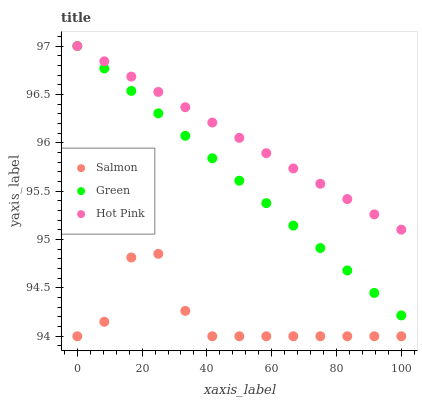Does Salmon have the minimum area under the curve?
Answer yes or no. Yes. Does Hot Pink have the maximum area under the curve?
Answer yes or no. Yes. Does Hot Pink have the minimum area under the curve?
Answer yes or no. No. Does Salmon have the maximum area under the curve?
Answer yes or no. No. Is Hot Pink the smoothest?
Answer yes or no. Yes. Is Salmon the roughest?
Answer yes or no. Yes. Is Salmon the smoothest?
Answer yes or no. No. Is Hot Pink the roughest?
Answer yes or no. No. Does Salmon have the lowest value?
Answer yes or no. Yes. Does Hot Pink have the lowest value?
Answer yes or no. No. Does Hot Pink have the highest value?
Answer yes or no. Yes. Does Salmon have the highest value?
Answer yes or no. No. Is Salmon less than Hot Pink?
Answer yes or no. Yes. Is Green greater than Salmon?
Answer yes or no. Yes. Does Green intersect Hot Pink?
Answer yes or no. Yes. Is Green less than Hot Pink?
Answer yes or no. No. Is Green greater than Hot Pink?
Answer yes or no. No. Does Salmon intersect Hot Pink?
Answer yes or no. No. 